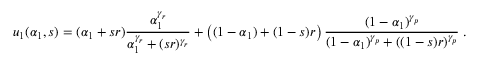Convert formula to latex. <formula><loc_0><loc_0><loc_500><loc_500>u _ { 1 } ( \alpha _ { 1 } , s ) = ( \alpha _ { 1 } + s r ) \frac { \alpha _ { 1 } ^ { \gamma _ { r } } } { \alpha _ { 1 } ^ { \gamma _ { r } } + ( s r ) ^ { \gamma _ { r } } } + \left ( ( 1 - \alpha _ { 1 } ) + ( 1 - s ) r \right ) \frac { ( 1 - \alpha _ { 1 } ) ^ { \gamma _ { p } } } { ( 1 - \alpha _ { 1 } ) ^ { \gamma _ { p } } + ( ( 1 - s ) r ) ^ { \gamma _ { p } } } \, .</formula> 